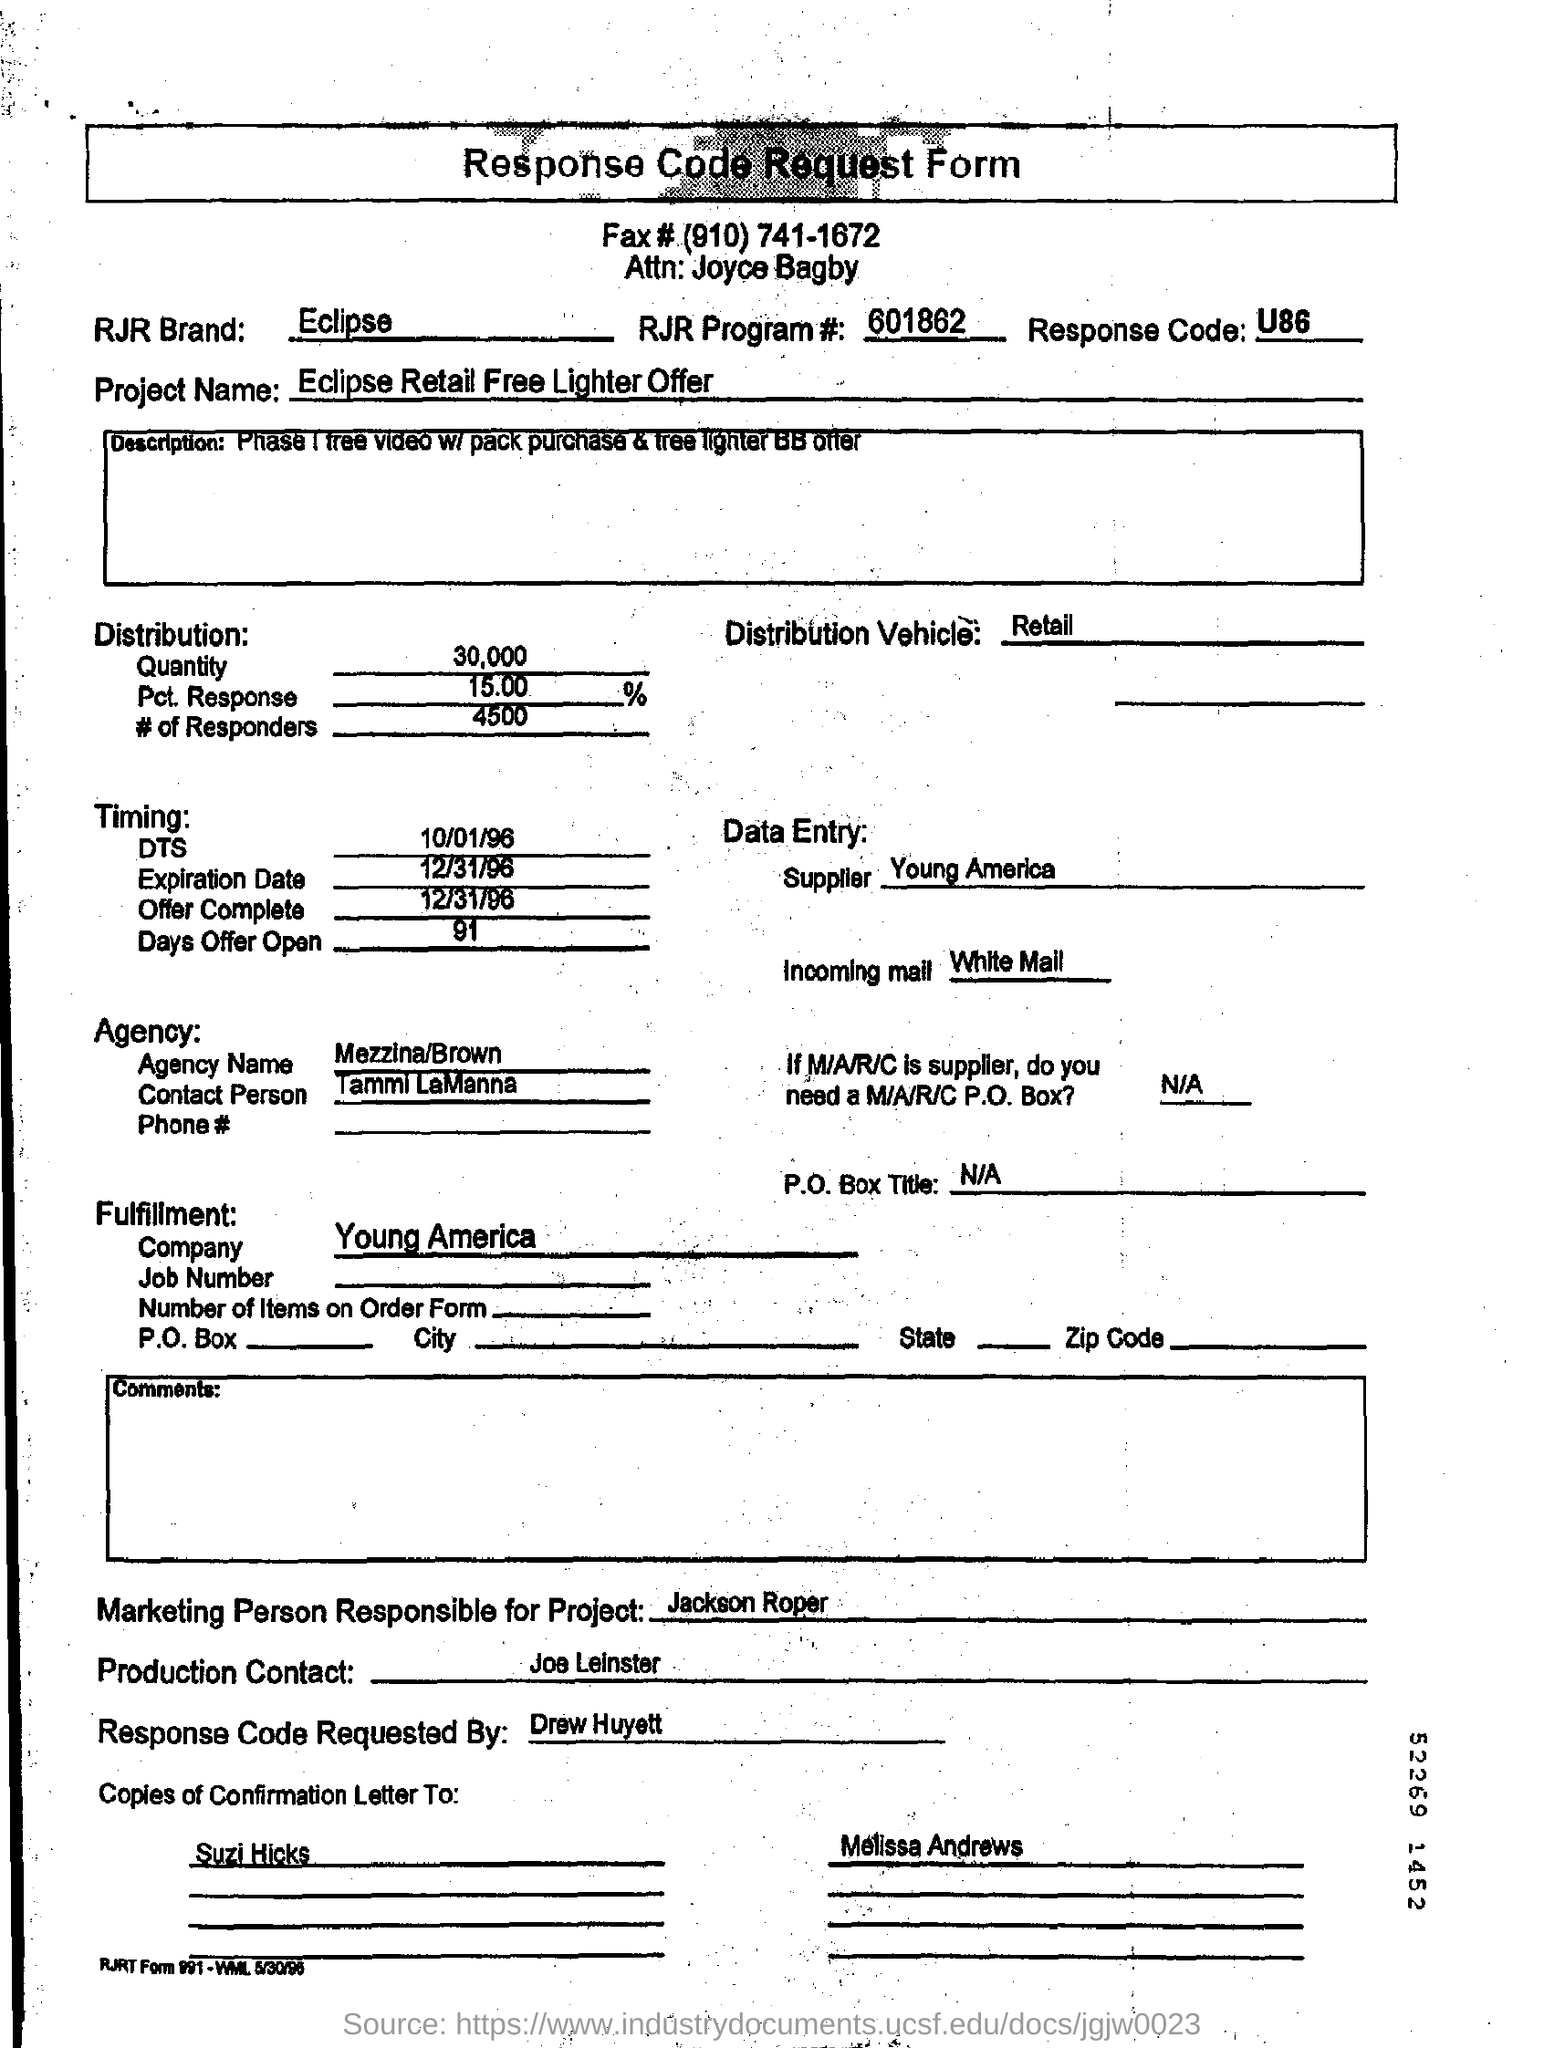What details are provided for the distribution of the offer? The form states that the offer's distribution entails a quantity of 30,000 with an expected response rate of 15%, amounting to approximately 4,500 responders. The distribution vehicle is indicated as retail. 